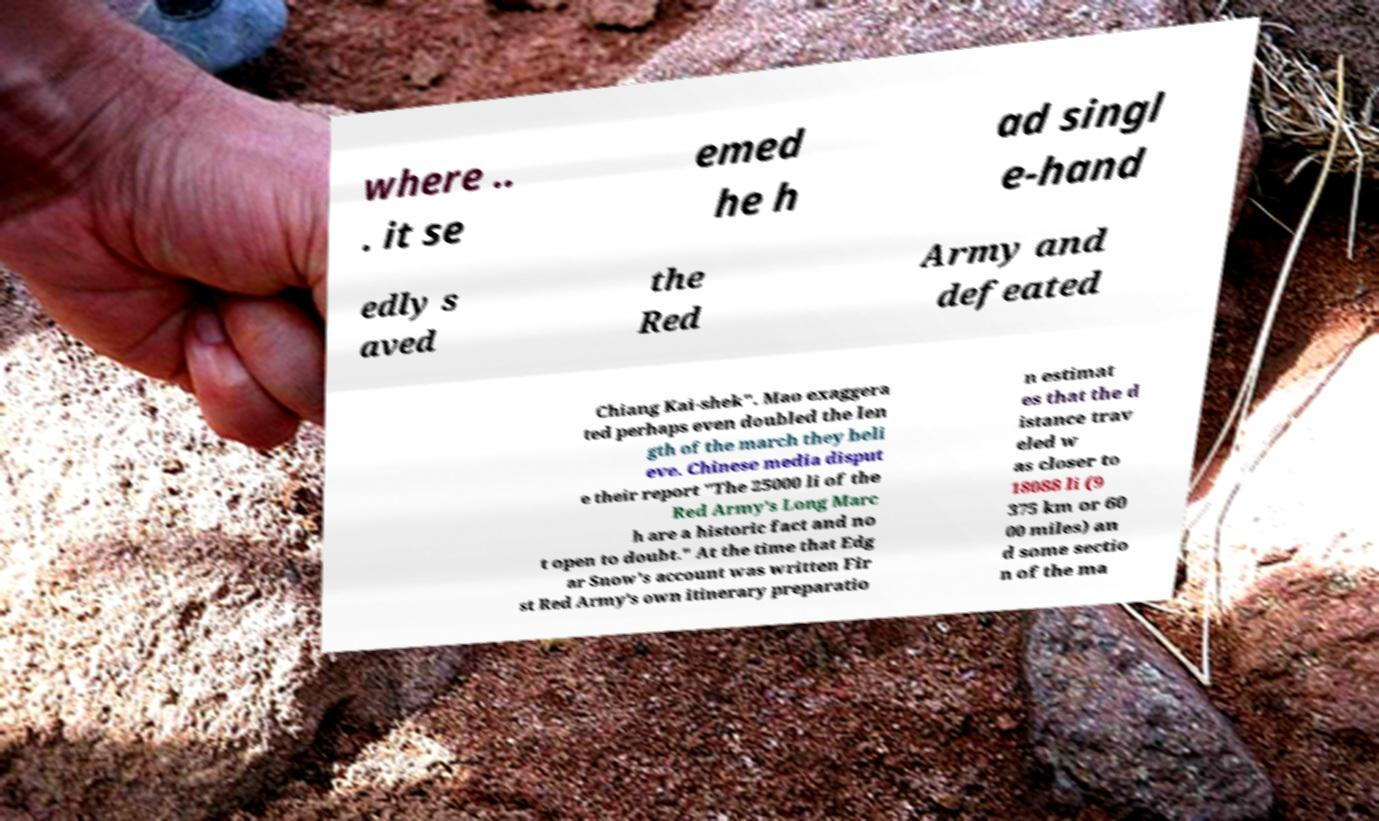Could you assist in decoding the text presented in this image and type it out clearly? where .. . it se emed he h ad singl e-hand edly s aved the Red Army and defeated Chiang Kai-shek". Mao exaggera ted perhaps even doubled the len gth of the march they beli eve. Chinese media disput e their report "The 25000 li of the Red Army's Long Marc h are a historic fact and no t open to doubt." At the time that Edg ar Snow's account was written Fir st Red Army's own itinerary preparatio n estimat es that the d istance trav eled w as closer to 18088 li (9 375 km or 60 00 miles) an d some sectio n of the ma 